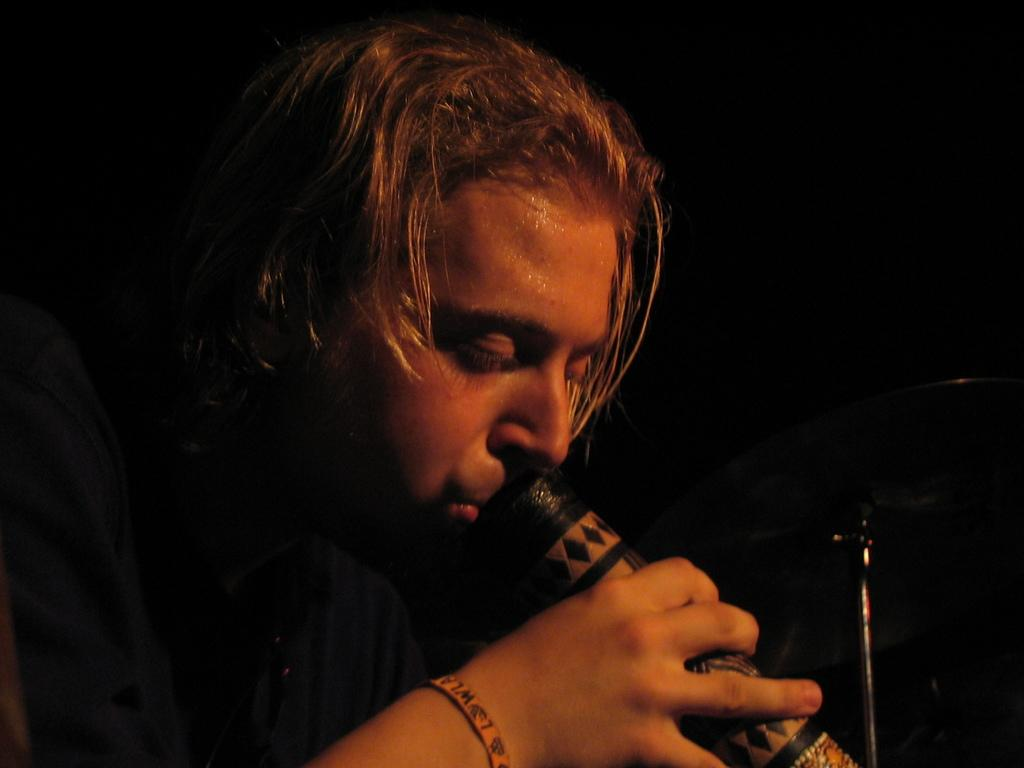Who or what is the main subject in the image? There is a person in the image. What is the person holding in the image? The person is holding a bottle. Can you describe the background of the image? The background of the image is dark. What type of sign can be seen in the image? There is no sign present in the image. What kind of sponge is being used by the person in the image? There is no sponge visible in the image, and the person is not using one. 